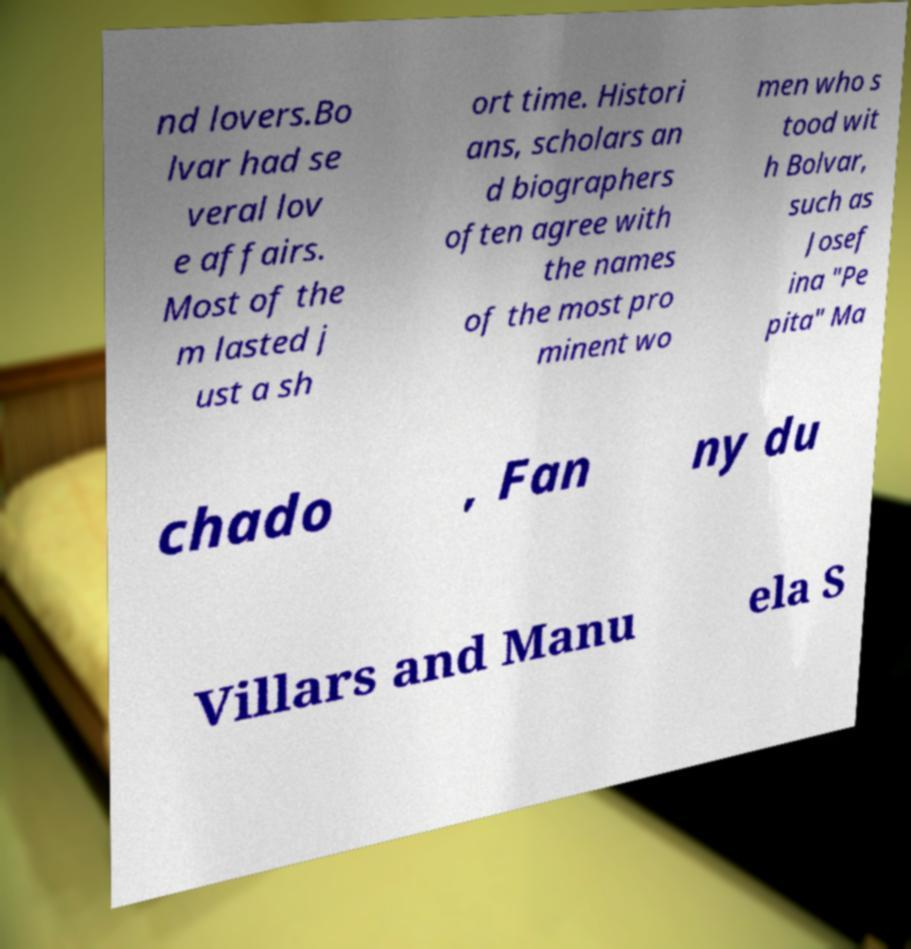What messages or text are displayed in this image? I need them in a readable, typed format. nd lovers.Bo lvar had se veral lov e affairs. Most of the m lasted j ust a sh ort time. Histori ans, scholars an d biographers often agree with the names of the most pro minent wo men who s tood wit h Bolvar, such as Josef ina "Pe pita" Ma chado , Fan ny du Villars and Manu ela S 